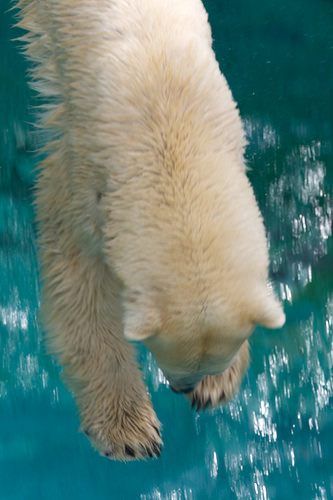<image>
Is the bear in the water? Yes. The bear is contained within or inside the water, showing a containment relationship. Where is the polar bear in relation to the water? Is it in the water? No. The polar bear is not contained within the water. These objects have a different spatial relationship. Is there a polar bear above the water? Yes. The polar bear is positioned above the water in the vertical space, higher up in the scene. 